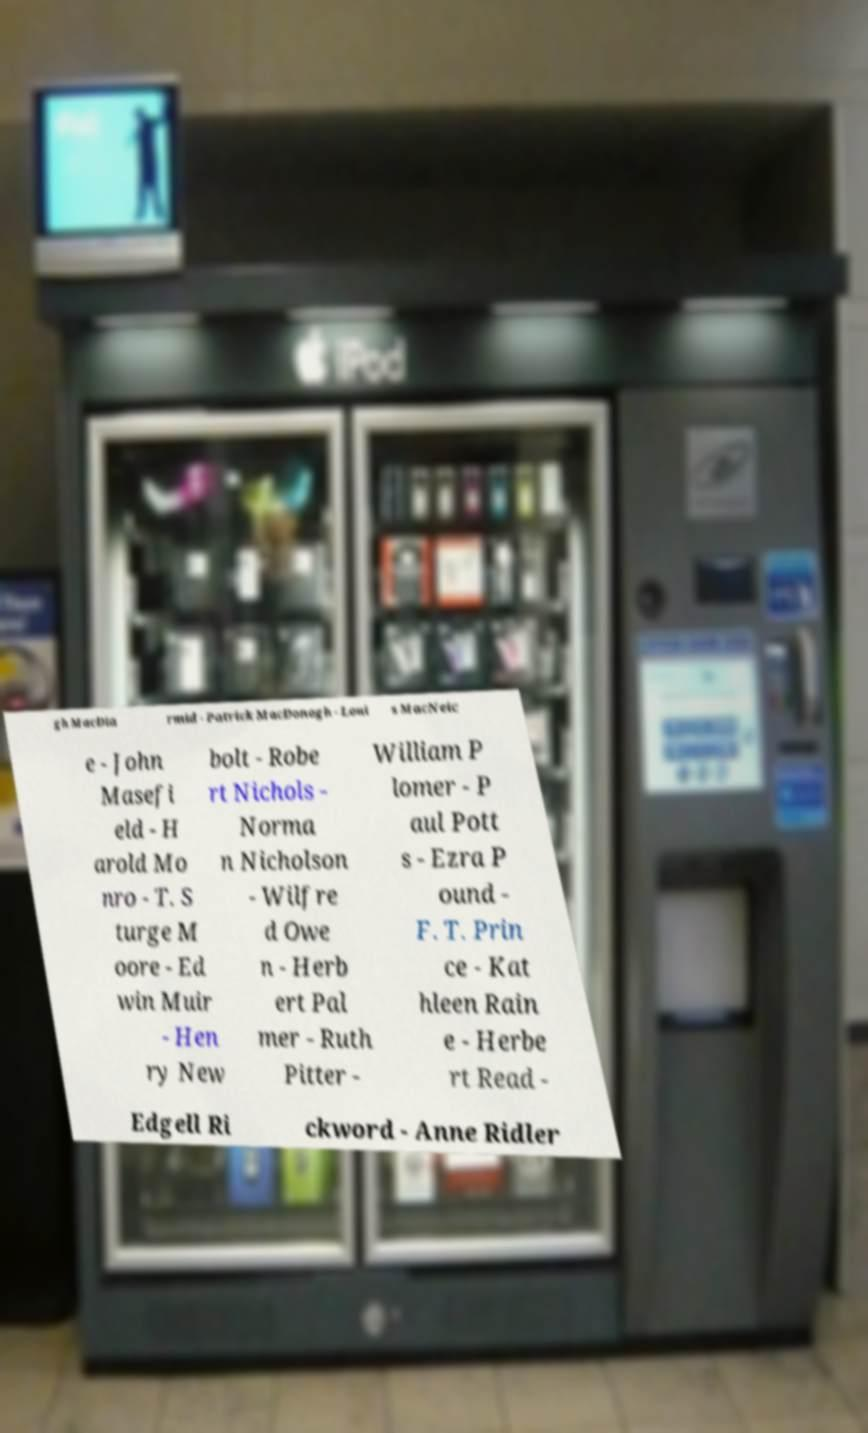For documentation purposes, I need the text within this image transcribed. Could you provide that? gh MacDia rmid - Patrick MacDonogh - Loui s MacNeic e - John Masefi eld - H arold Mo nro - T. S turge M oore - Ed win Muir - Hen ry New bolt - Robe rt Nichols - Norma n Nicholson - Wilfre d Owe n - Herb ert Pal mer - Ruth Pitter - William P lomer - P aul Pott s - Ezra P ound - F. T. Prin ce - Kat hleen Rain e - Herbe rt Read - Edgell Ri ckword - Anne Ridler 